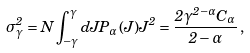<formula> <loc_0><loc_0><loc_500><loc_500>\sigma _ { \gamma } ^ { 2 } = N \int _ { - \gamma } ^ { \gamma } d J P _ { \alpha } ( J ) J ^ { 2 } = \frac { 2 \gamma ^ { 2 - \alpha } C _ { \alpha } } { 2 - \alpha } \, ,</formula> 